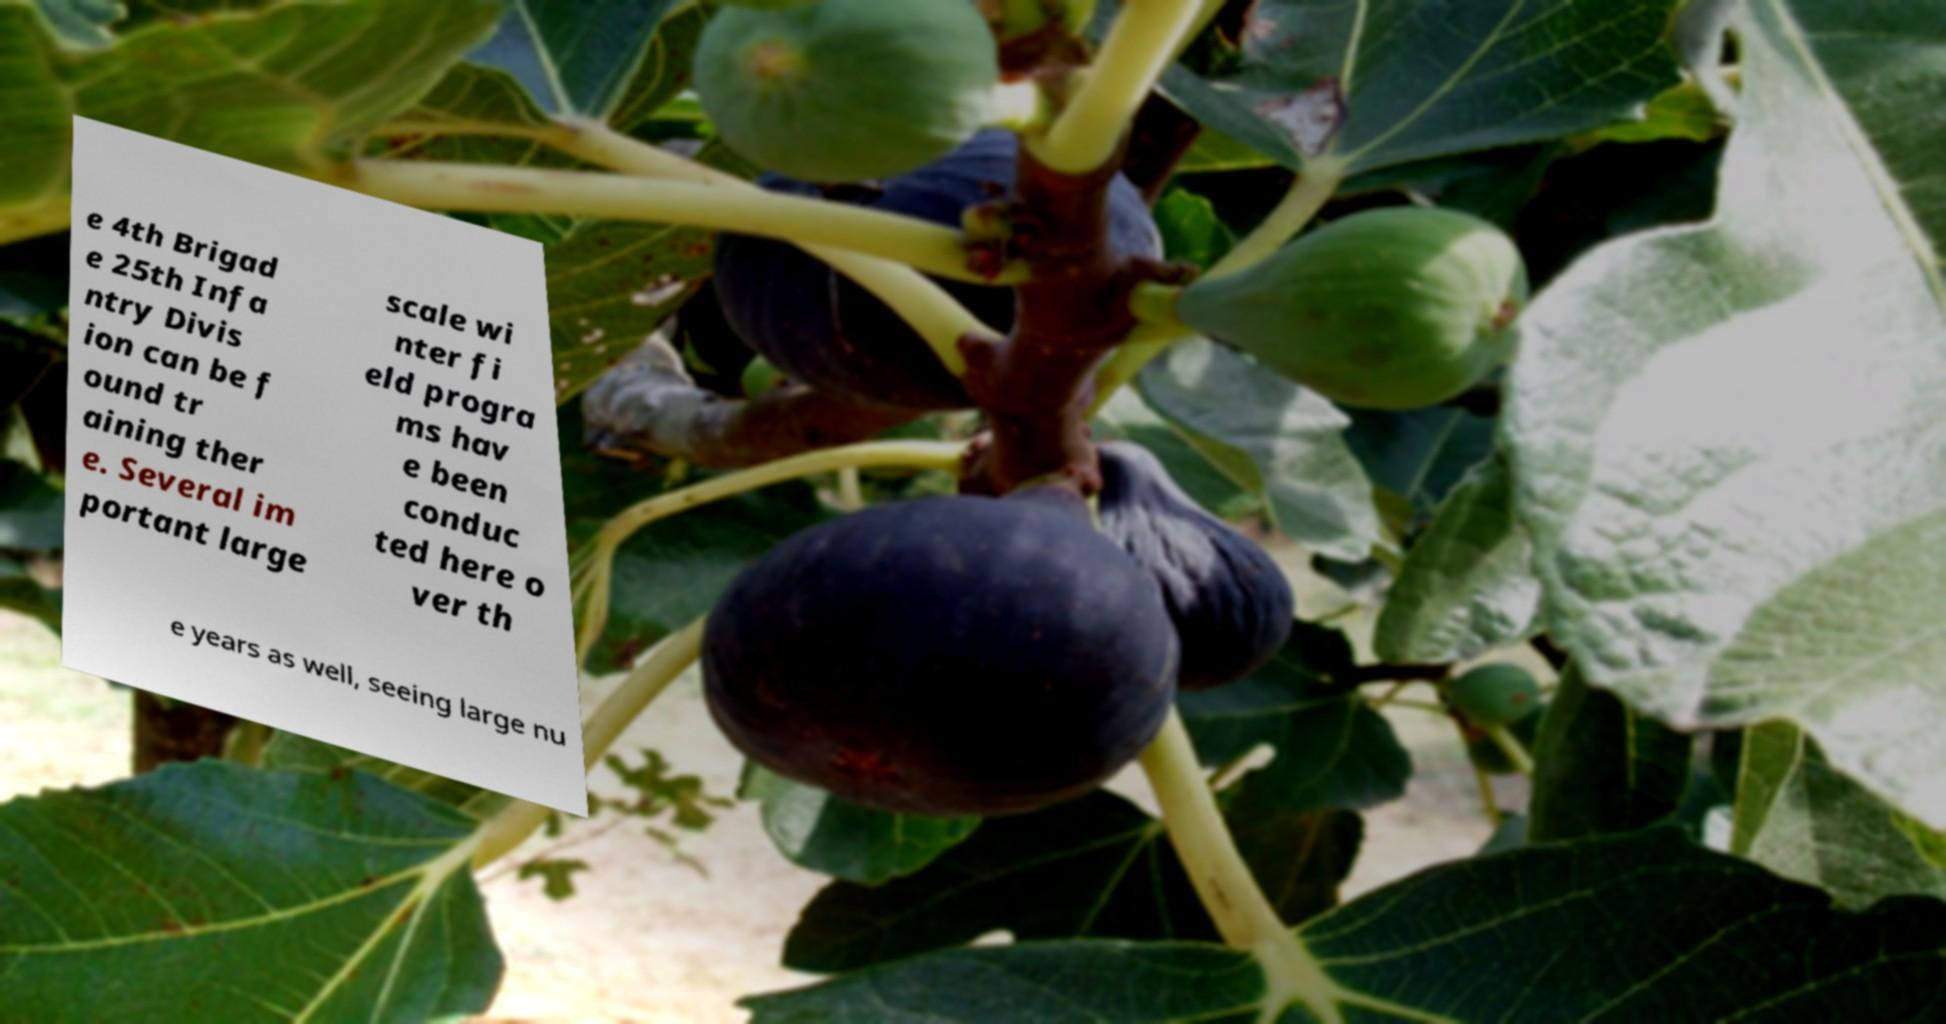Can you read and provide the text displayed in the image?This photo seems to have some interesting text. Can you extract and type it out for me? e 4th Brigad e 25th Infa ntry Divis ion can be f ound tr aining ther e. Several im portant large scale wi nter fi eld progra ms hav e been conduc ted here o ver th e years as well, seeing large nu 